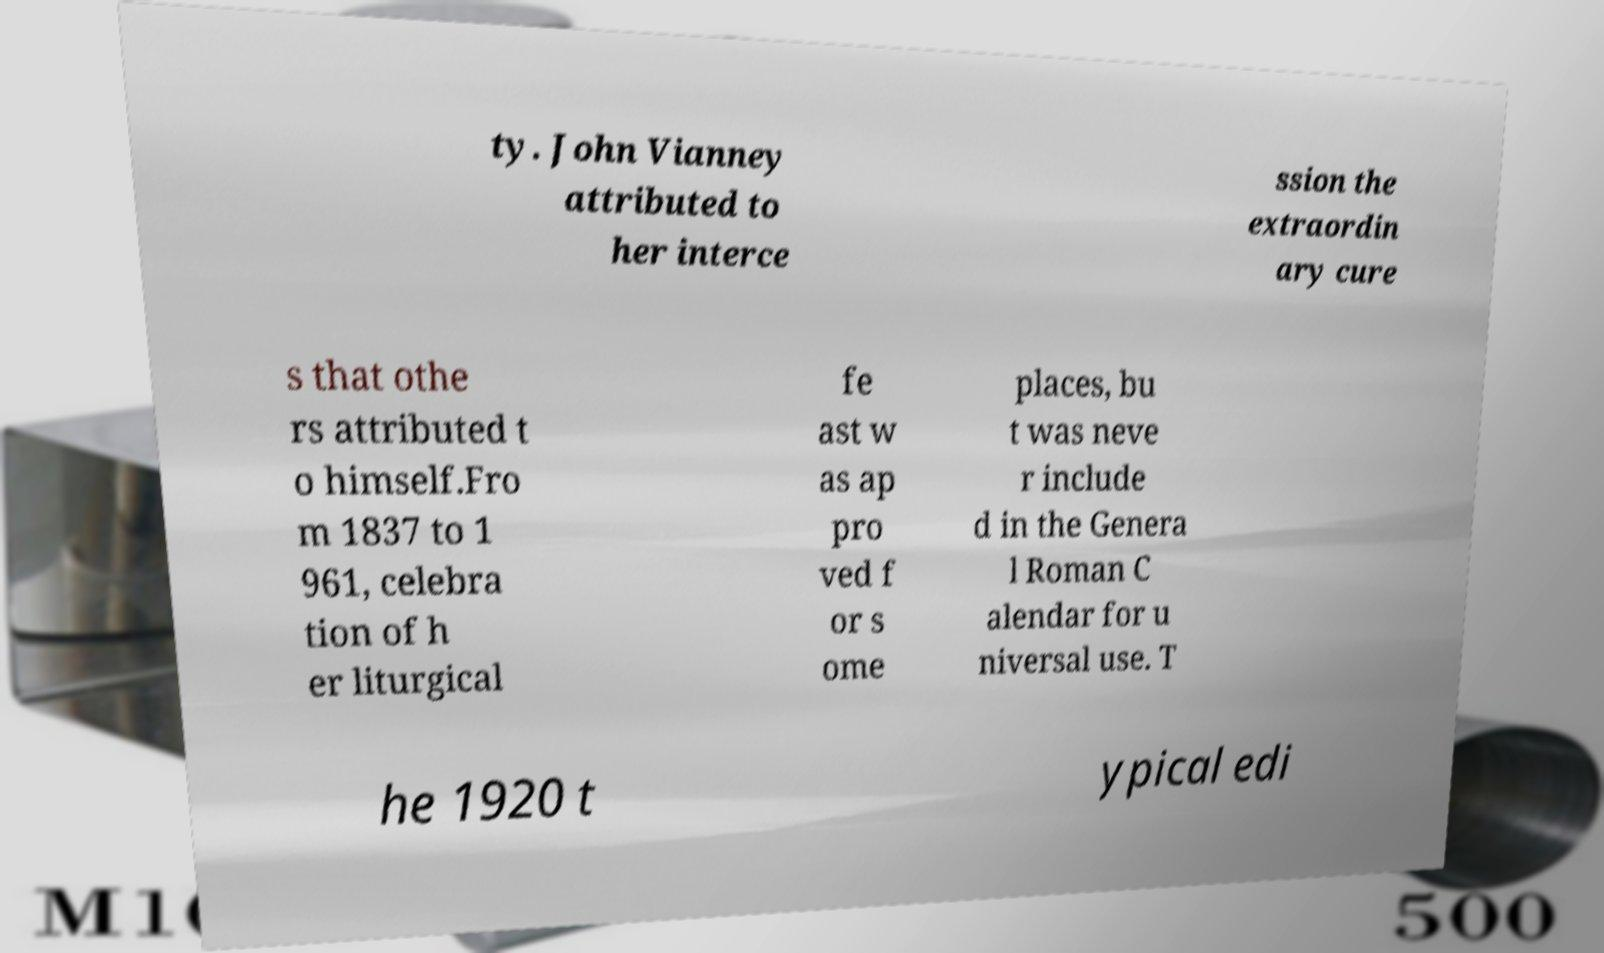Could you assist in decoding the text presented in this image and type it out clearly? ty. John Vianney attributed to her interce ssion the extraordin ary cure s that othe rs attributed t o himself.Fro m 1837 to 1 961, celebra tion of h er liturgical fe ast w as ap pro ved f or s ome places, bu t was neve r include d in the Genera l Roman C alendar for u niversal use. T he 1920 t ypical edi 